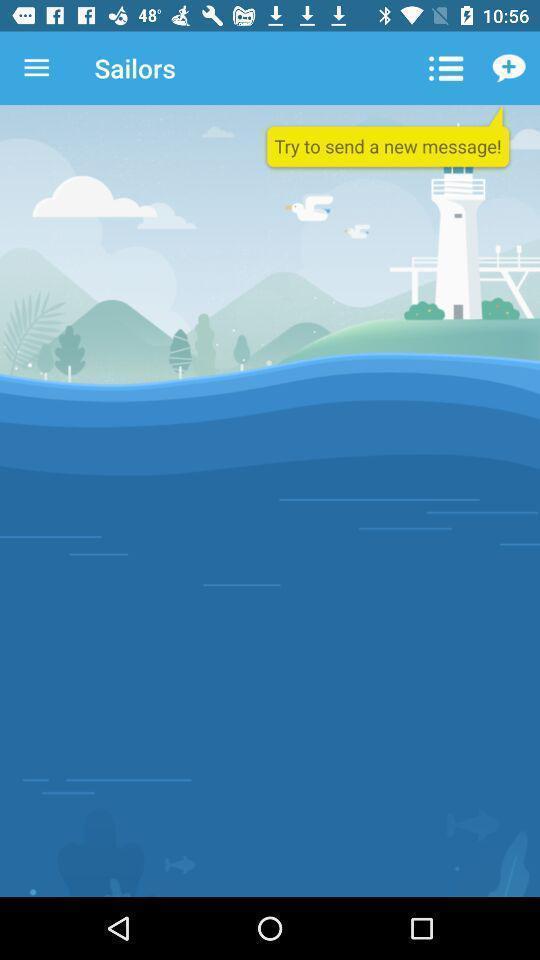What details can you identify in this image? Pop up showing to send a new message. 